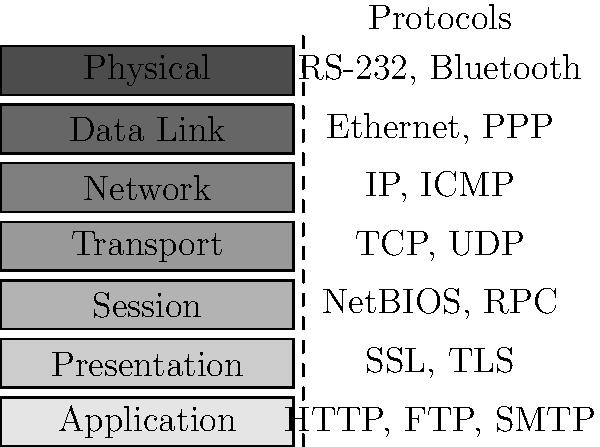In the OSI model stack diagram, which layer is responsible for routing and addressing, and what are two common protocols associated with this layer? To answer this question, we need to analyze the OSI model layers and their associated protocols:

1. The OSI model consists of 7 layers, from bottom to top: Physical, Data Link, Network, Transport, Session, Presentation, and Application.

2. Each layer has specific responsibilities and associated protocols.

3. The layer responsible for routing and addressing is the Network layer (Layer 3).

4. Looking at the diagram, we can see that the Network layer is associated with two protocols: IP and ICMP.

5. IP (Internet Protocol) is the primary protocol used for addressing and routing packets across networks.

6. ICMP (Internet Control Message Protocol) is used for error reporting and network diagnostics.

Therefore, the Network layer is responsible for routing and addressing, and the two common protocols associated with this layer are IP and ICMP.
Answer: Network layer; IP and ICMP 